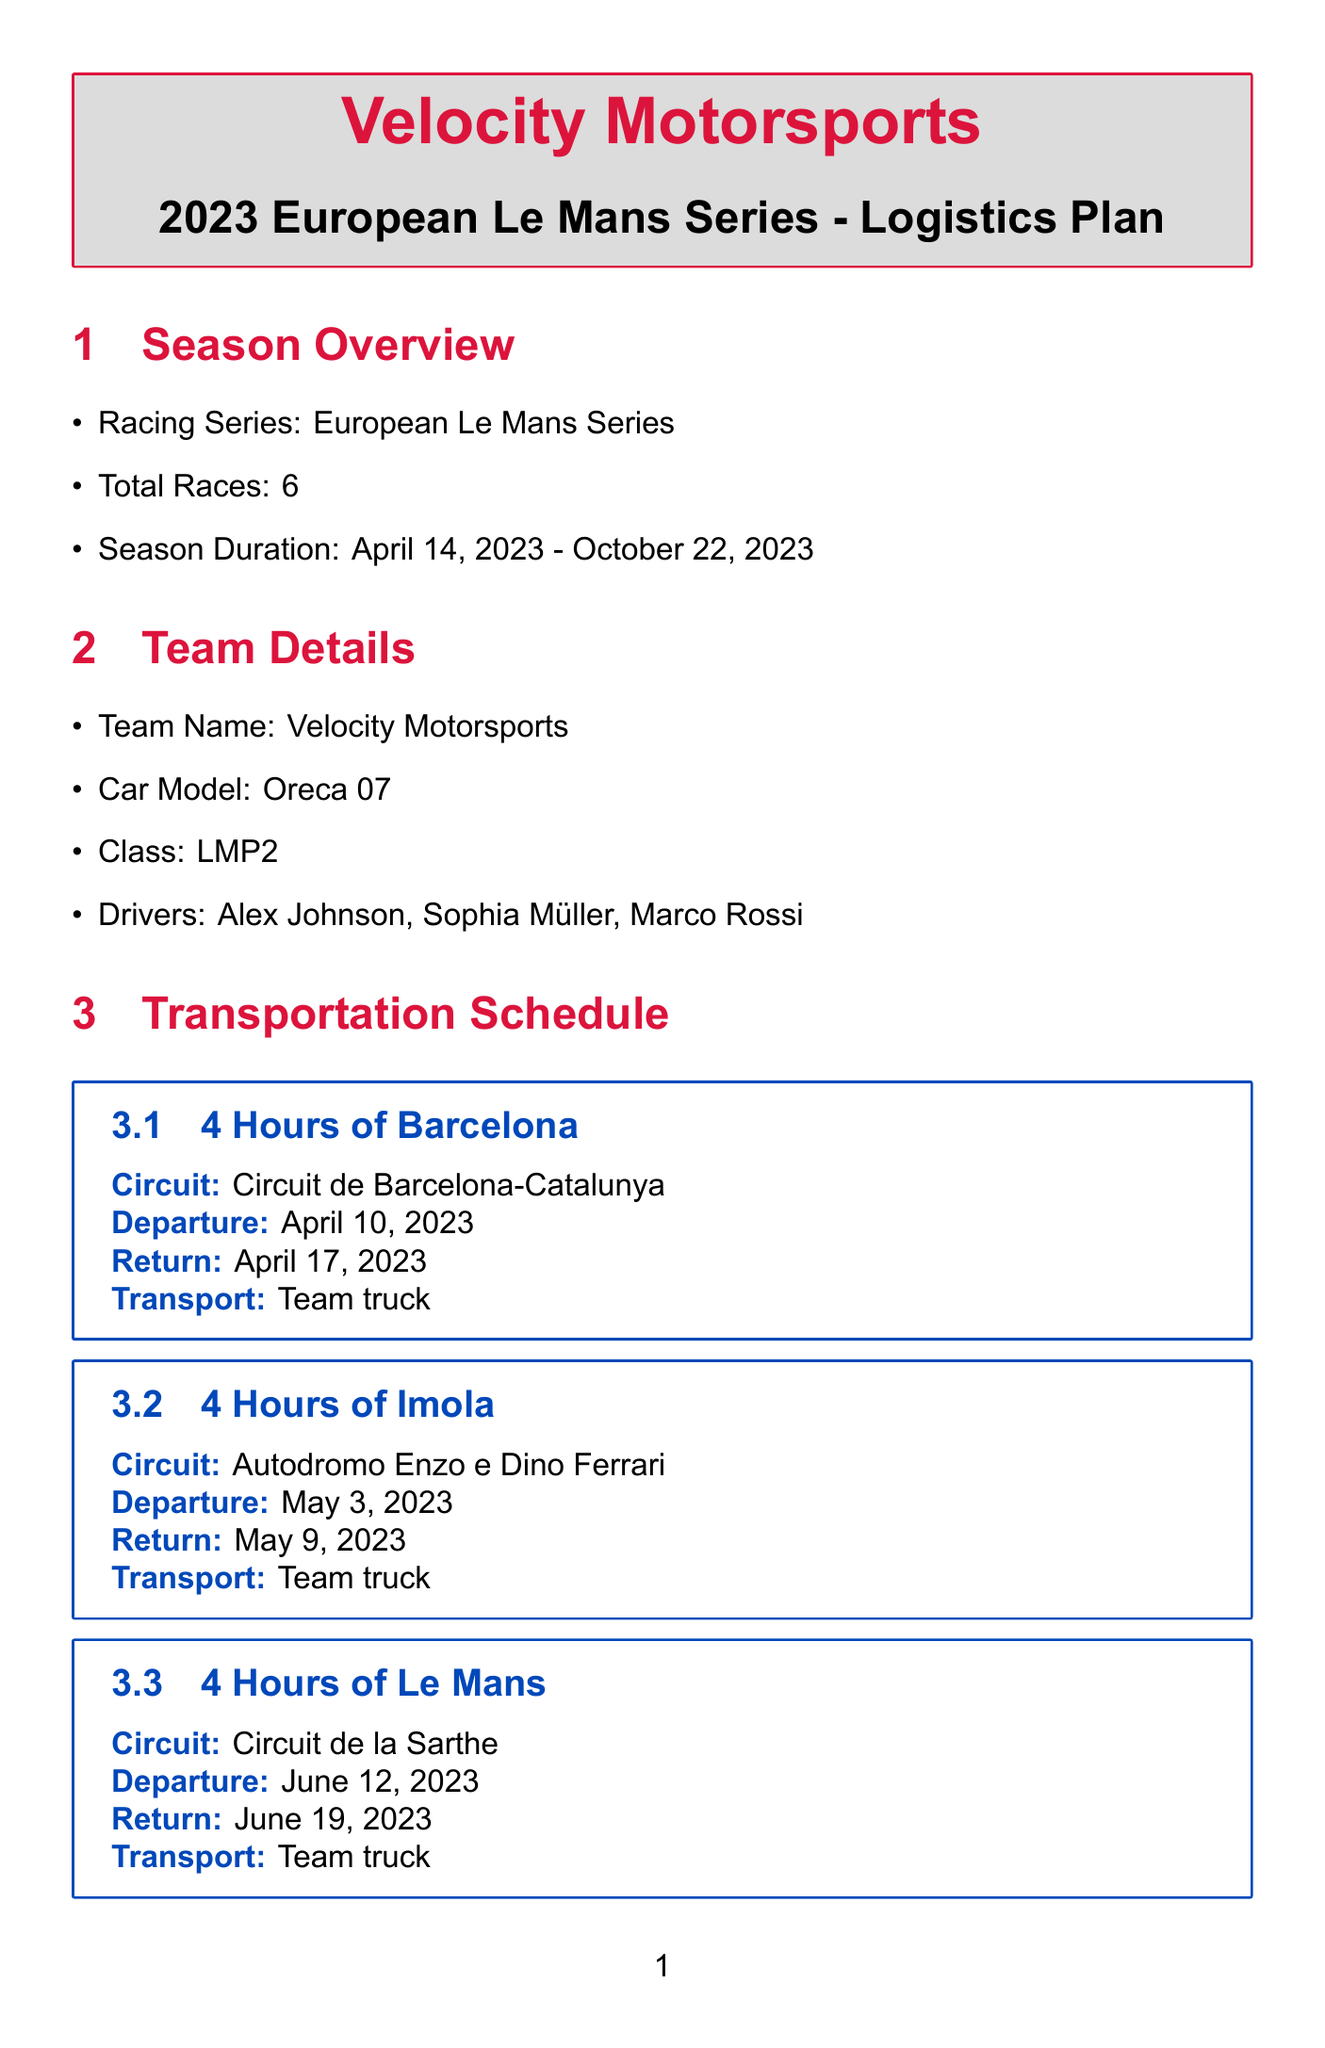What is the total number of races? The total number of races is explicitly stated in the season overview section of the document.
Answer: 6 When does the season start? The season start date is listed in the season overview section, specifying when the racing series begins.
Answer: April 14, 2023 What is the transportation budget? The budget allocation section provides specific amounts allocated for each category, including transportation.
Answer: €150,000 Which hotel is booked for the 4 Hours of Le Mans? The crew accommodation section lists the hotel arrangements for each race, including for Le Mans.
Answer: Hôtel Concordia Le Mans Centre How many spare parts are listed for the race car? The equipment inventory section details different spare parts available for the race car by counting the items listed.
Answer: 5 Who is the team manager? The team personnel section identifies the roles and numbers of team members, including the team manager.
Answer: 1 What is the check-out date for the Portimão race accommodation? The crew accommodation section provides specific check-in and check-out dates for each race hotel, including for Portimão.
Answer: October 23, 2023 What is the car model used by this team? The team details explicitly mention the car model being used by Velocity Motorsports.
Answer: Oreca 07 How many mechanics are on the team? The team personnel section specifies the number of mechanics as part of the overall staffing details.
Answer: 6 